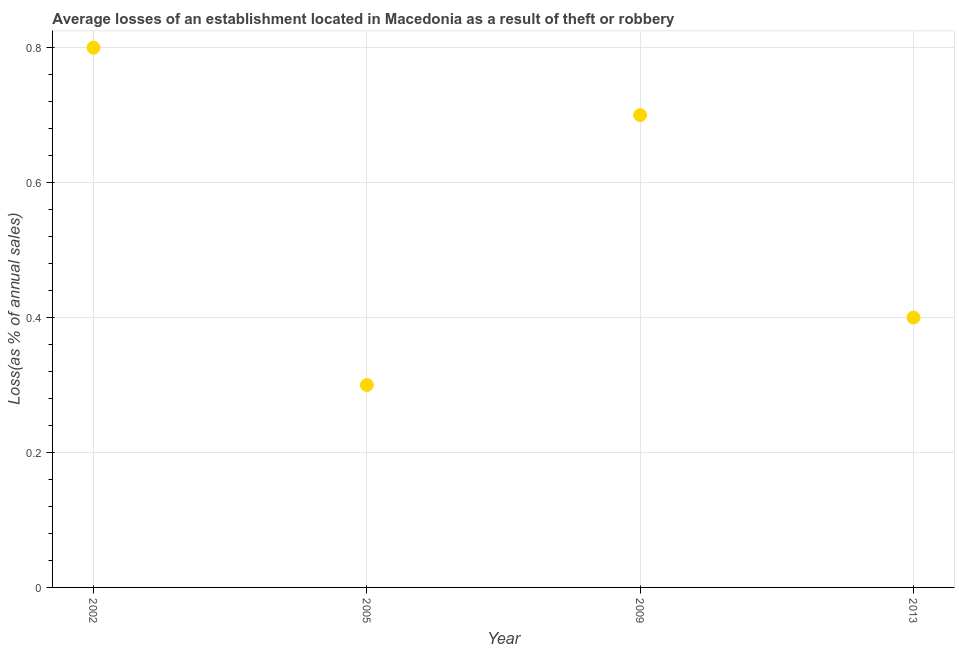Across all years, what is the minimum losses due to theft?
Keep it short and to the point. 0.3. In which year was the losses due to theft maximum?
Make the answer very short. 2002. What is the sum of the losses due to theft?
Provide a succinct answer. 2.2. What is the difference between the losses due to theft in 2005 and 2009?
Your answer should be compact. -0.4. What is the average losses due to theft per year?
Provide a short and direct response. 0.55. What is the median losses due to theft?
Your answer should be compact. 0.55. What is the ratio of the losses due to theft in 2002 to that in 2009?
Your answer should be very brief. 1.14. What is the difference between the highest and the second highest losses due to theft?
Offer a very short reply. 0.1. Is the sum of the losses due to theft in 2009 and 2013 greater than the maximum losses due to theft across all years?
Your response must be concise. Yes. In how many years, is the losses due to theft greater than the average losses due to theft taken over all years?
Offer a terse response. 2. How many years are there in the graph?
Provide a succinct answer. 4. What is the difference between two consecutive major ticks on the Y-axis?
Provide a short and direct response. 0.2. Does the graph contain any zero values?
Ensure brevity in your answer.  No. Does the graph contain grids?
Ensure brevity in your answer.  Yes. What is the title of the graph?
Offer a terse response. Average losses of an establishment located in Macedonia as a result of theft or robbery. What is the label or title of the X-axis?
Offer a very short reply. Year. What is the label or title of the Y-axis?
Provide a succinct answer. Loss(as % of annual sales). What is the Loss(as % of annual sales) in 2005?
Provide a succinct answer. 0.3. What is the difference between the Loss(as % of annual sales) in 2002 and 2013?
Provide a succinct answer. 0.4. What is the difference between the Loss(as % of annual sales) in 2005 and 2013?
Provide a short and direct response. -0.1. What is the difference between the Loss(as % of annual sales) in 2009 and 2013?
Your answer should be compact. 0.3. What is the ratio of the Loss(as % of annual sales) in 2002 to that in 2005?
Your answer should be very brief. 2.67. What is the ratio of the Loss(as % of annual sales) in 2002 to that in 2009?
Offer a terse response. 1.14. What is the ratio of the Loss(as % of annual sales) in 2005 to that in 2009?
Make the answer very short. 0.43. What is the ratio of the Loss(as % of annual sales) in 2005 to that in 2013?
Make the answer very short. 0.75. What is the ratio of the Loss(as % of annual sales) in 2009 to that in 2013?
Ensure brevity in your answer.  1.75. 